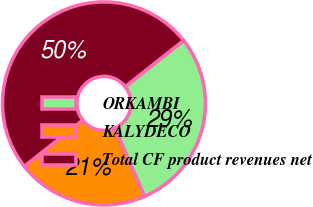Convert chart. <chart><loc_0><loc_0><loc_500><loc_500><pie_chart><fcel>ORKAMBI<fcel>KALYDECO<fcel>Total CF product revenues net<nl><fcel>29.1%<fcel>20.9%<fcel>50.0%<nl></chart> 